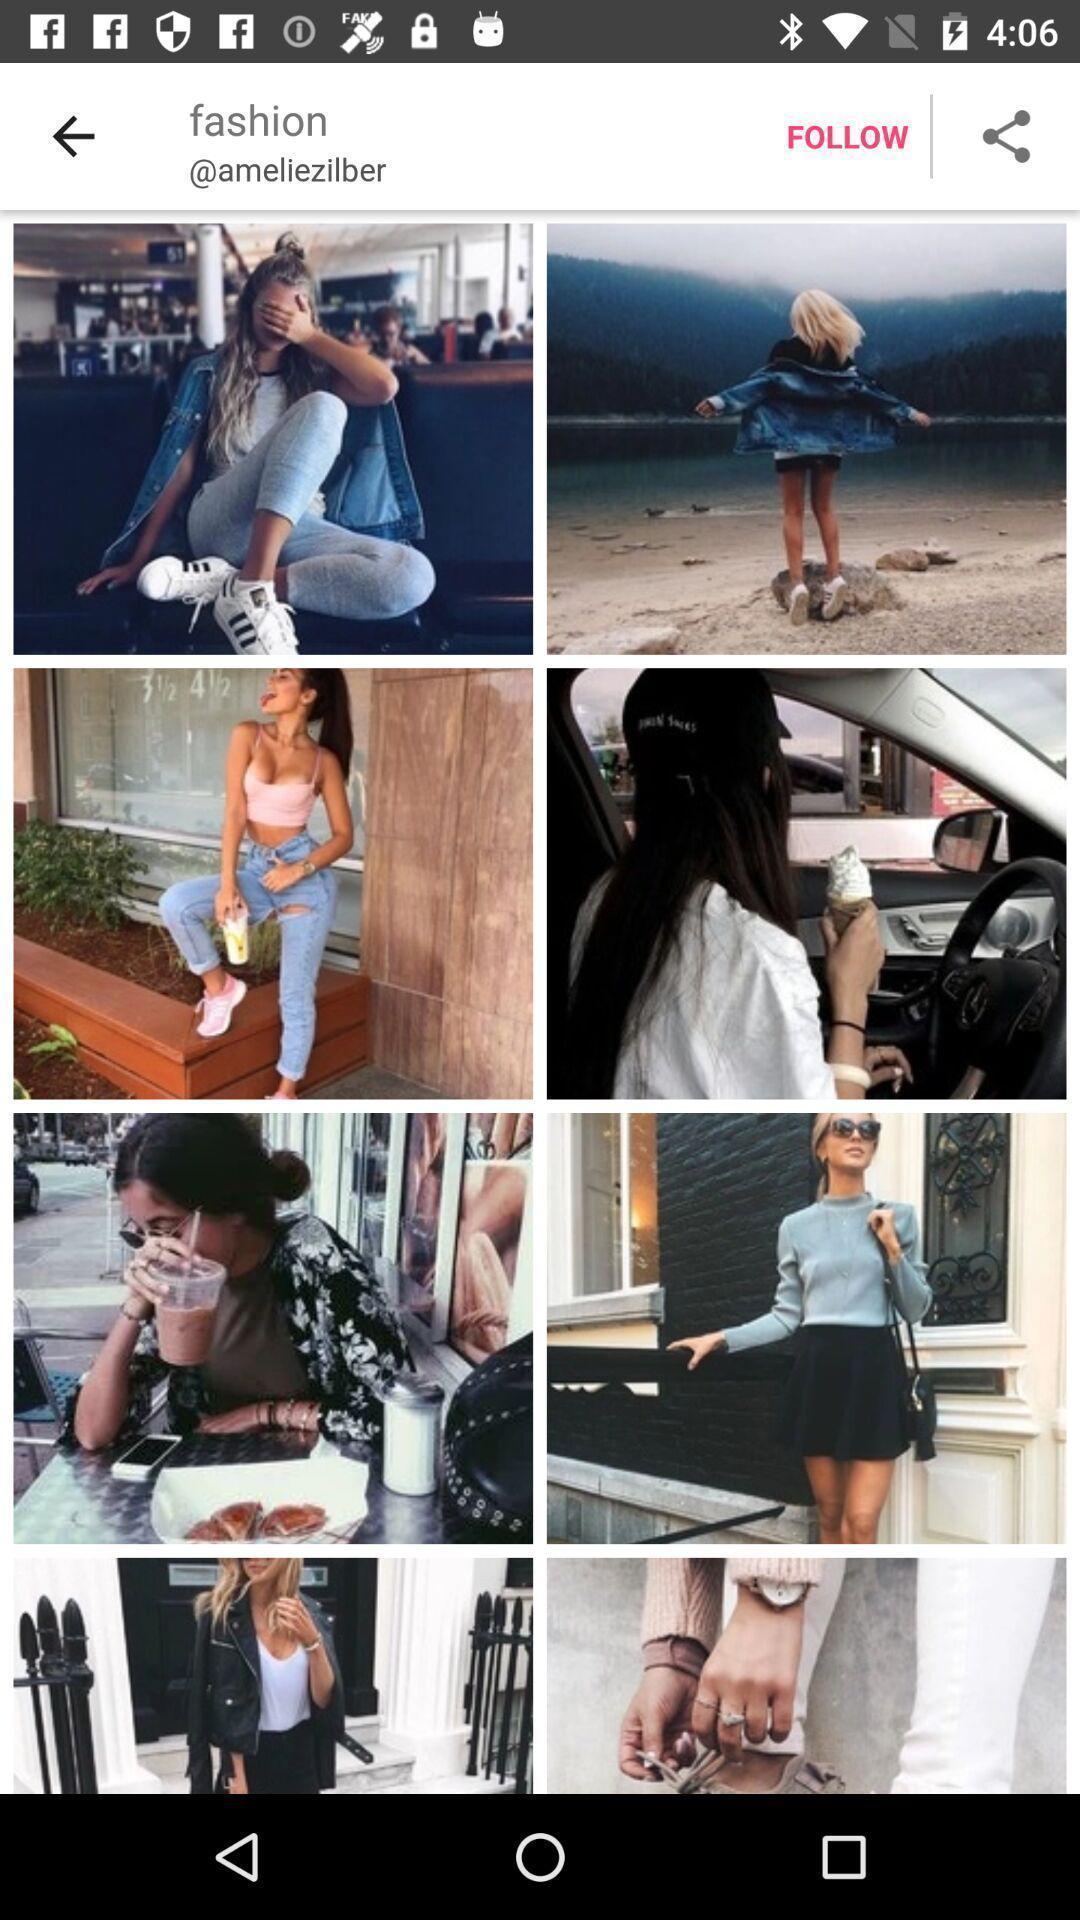Give me a narrative description of this picture. Screen display various fashion images. 